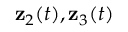<formula> <loc_0><loc_0><loc_500><loc_500>{ z } _ { 2 } ( t ) , { z } _ { 3 } ( t )</formula> 